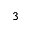<formula> <loc_0><loc_0><loc_500><loc_500>^ { 3 }</formula> 